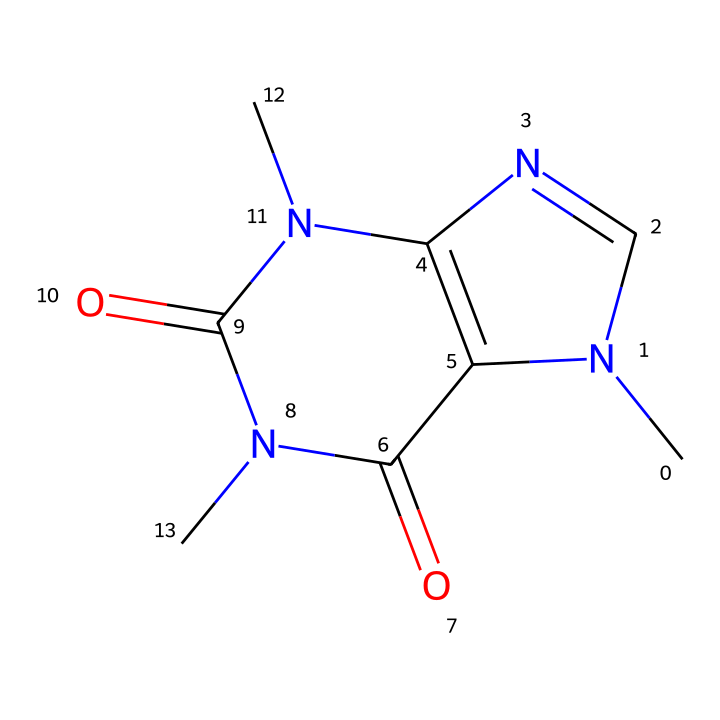What is the molecular formula of caffeine? By breaking down the SMILES representation, we can identify the atoms present: there are 8 carbon (C) atoms, 10 hydrogen (H) atoms, 4 nitrogen (N) atoms, and 2 oxygen (O) atoms. Thus, the molecular formula is C8H10N4O2.
Answer: C8H10N4O2 How many nitrogen atoms are present in the structure? From the SMILES, we can see that there are 4 occurrences of 'N', indicating 4 nitrogen atoms in the caffeine structure.
Answer: 4 What is the structure type of caffeine? Since caffeine contains nitrogen in its structure in addition to carbon and hydrogen, and given the specific arrangement of these atoms, it is classified as an alkaloid.
Answer: alkaloid How many rings are present in the caffeine structure? Analyzing the SMILES, we note there are two instances of ring closure indicators (the digits '1' and '2') which indicate the start and end of rings. This confirms that the structure has 2 rings.
Answer: 2 What is the functional group present in caffeine? The functional groups implied in the SMILES include a carbonyl (C=O) implied by 'C(=O)' repeated in the structure, which is characteristic of amides. Therefore, caffeine contains amide functional groups.
Answer: amide What type of reaction would most likely modify caffeine given its nitrogen composition? Due to the presence of nitrogen atoms, caffeine could undergo methylation reactions, which involve adding a methyl group (–CH3) to the nitrogen atoms in the structure. This property is typical of many alkaloids.
Answer: methylation 